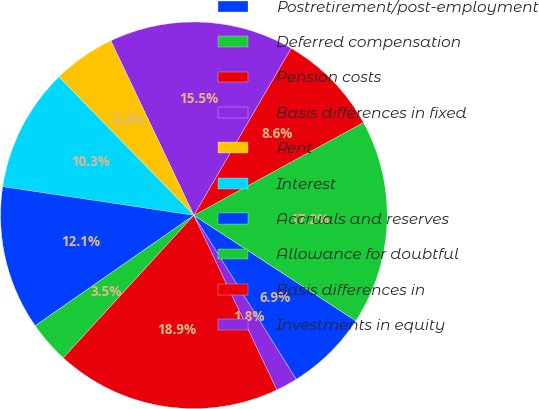Convert chart to OTSL. <chart><loc_0><loc_0><loc_500><loc_500><pie_chart><fcel>Postretirement/post-employment<fcel>Deferred compensation<fcel>Pension costs<fcel>Basis differences in fixed<fcel>Rent<fcel>Interest<fcel>Accruals and reserves<fcel>Allowance for doubtful<fcel>Basis differences in<fcel>Investments in equity<nl><fcel>6.93%<fcel>17.16%<fcel>8.64%<fcel>15.46%<fcel>5.22%<fcel>10.34%<fcel>12.05%<fcel>3.52%<fcel>18.87%<fcel>1.81%<nl></chart> 